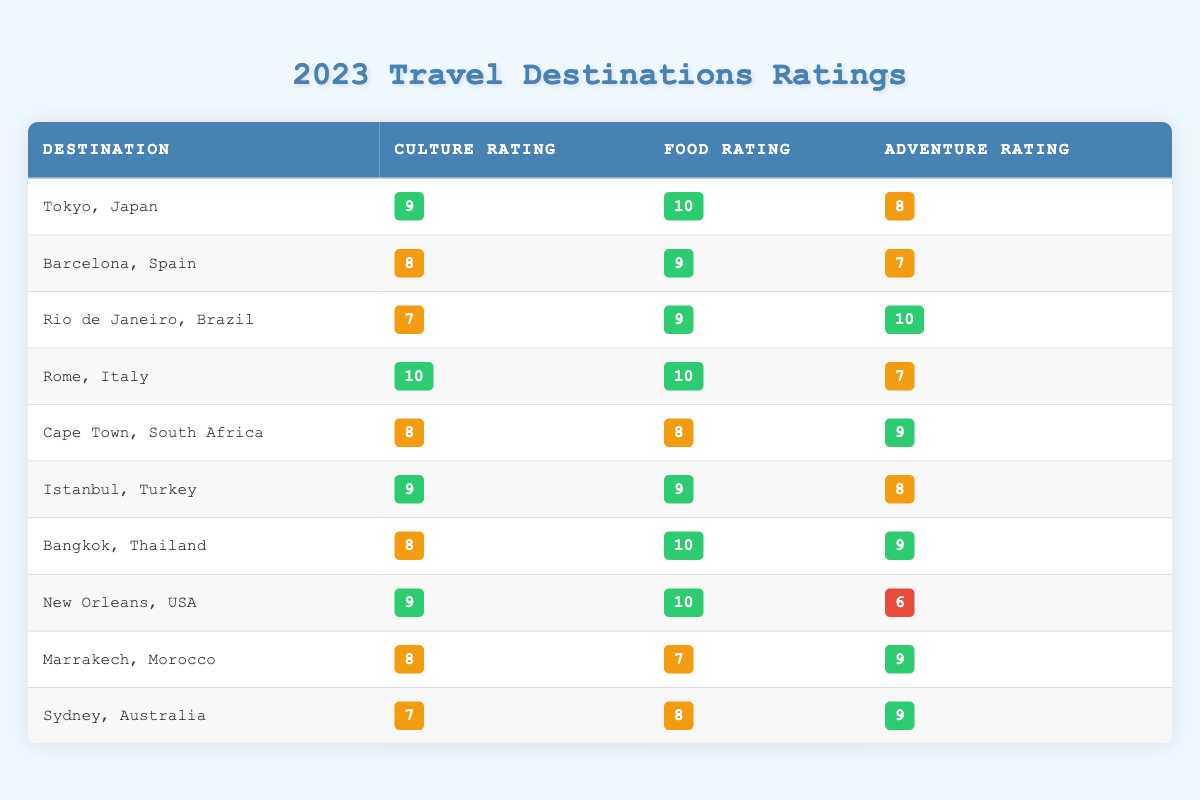What is the highest Culture Rating among the destinations? The highest Culture Rating in the table is 10, which is given for Rome, Italy.
Answer: 10 Which destination received a Food Rating of 10? The destinations that received a Food Rating of 10 are Tokyo, Japan, Rome, Italy, New Orleans, USA, and Bangkok, Thailand.
Answer: Tokyo, Rome, New Orleans, Bangkok What is the Adventure Rating for Cape Town, South Africa? Looking at the table, Cape Town, South Africa has an Adventure Rating of 9.
Answer: 9 Which destination had the lowest Adventure Rating? The destination with the lowest Adventure Rating is New Orleans, USA, with a rating of 6.
Answer: New Orleans, USA What is the average Culture Rating for all the destinations? To find the average Culture Rating, we sum the Ratings: (9 + 8 + 7 + 10 + 8 + 9 + 8 + 9 + 8 + 7) = 81, then divide by 10 (the number of destinations), which gives us 81/10 = 8.1.
Answer: 8.1 Is the Food Rating for Rio de Janeiro higher than its Adventure Rating? Rio de Janeiro has a Food Rating of 9 and an Adventure Rating of 10. Since 9 is not higher than 10, the statement is false.
Answer: No Which destinations have a Culture Rating of 9 or higher? The destinations with a Culture Rating of 9 or higher are Tokyo, Japan; Rome, Italy; Istanbul, Turkey; and New Orleans, USA.
Answer: Tokyo, Rome, Istanbul, New Orleans Calculate the difference between the highest and lowest Food Ratings. The highest Food Rating is 10 (Tokyo, Rome, New Orleans, Bangkok), and the lowest is 7 (Marrakech). The difference is 10 - 7 = 3.
Answer: 3 How many destinations received an Adventure Rating of 9? The destinations with an Adventure Rating of 9 are Cape Town, Bangkok, and Sydney. That gives us a total of 3 destinations.
Answer: 3 Which destination scored a perfect rating in both Culture and Food? Rome, Italy scored a perfect rating of 10 in both Culture and Food.
Answer: Rome, Italy 